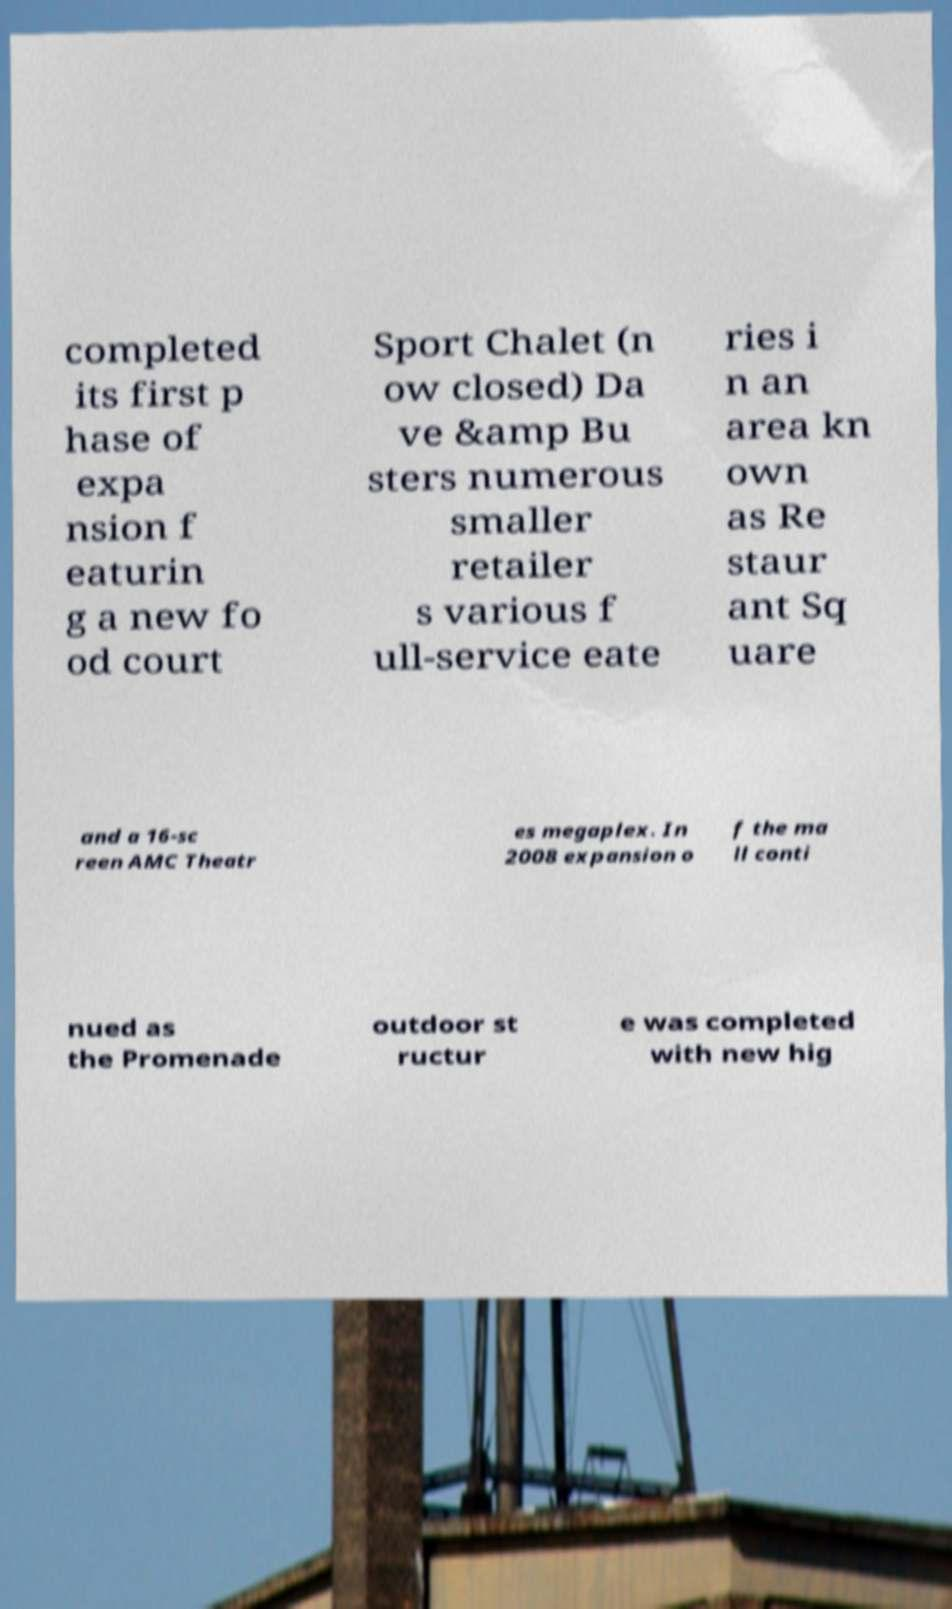For documentation purposes, I need the text within this image transcribed. Could you provide that? completed its first p hase of expa nsion f eaturin g a new fo od court Sport Chalet (n ow closed) Da ve &amp Bu sters numerous smaller retailer s various f ull-service eate ries i n an area kn own as Re staur ant Sq uare and a 16-sc reen AMC Theatr es megaplex. In 2008 expansion o f the ma ll conti nued as the Promenade outdoor st ructur e was completed with new hig 